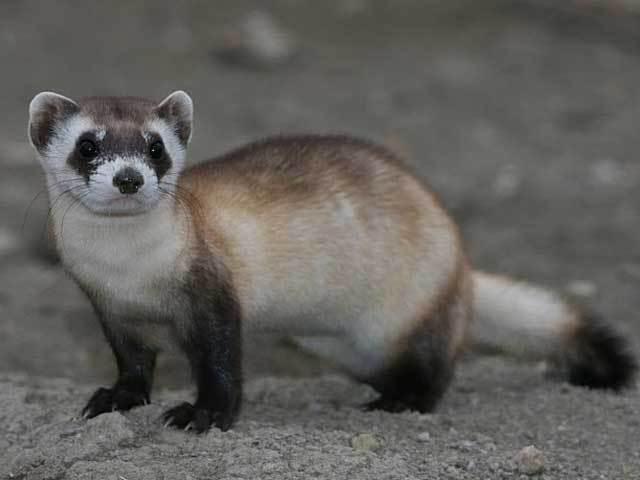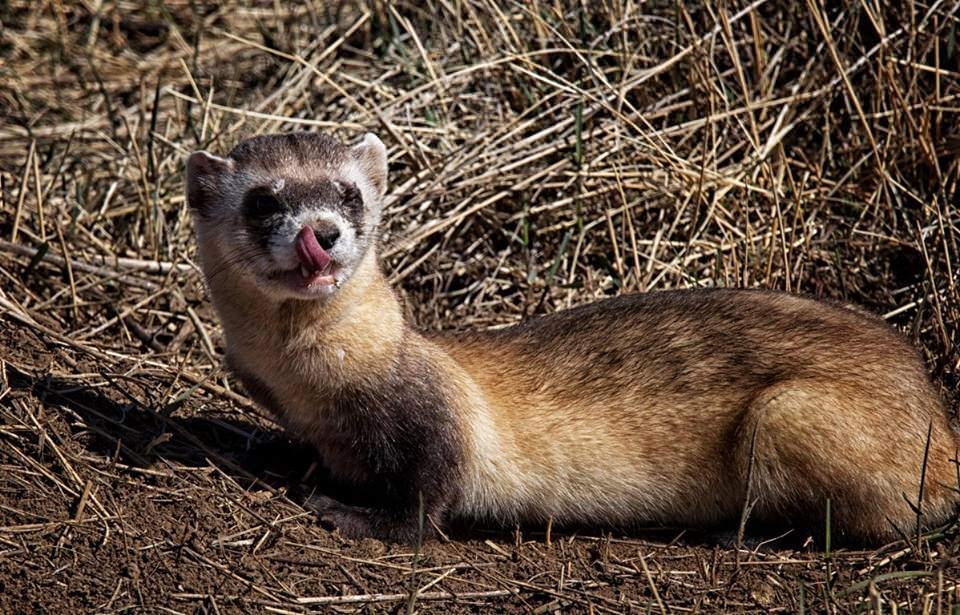The first image is the image on the left, the second image is the image on the right. Assess this claim about the two images: "In one of the images there are 2 animals.". Correct or not? Answer yes or no. No. The first image is the image on the left, the second image is the image on the right. Analyze the images presented: Is the assertion "The combined images include two ferrets in very similar poses, with heads turned the same direction, and all ferrets have raised heads." valid? Answer yes or no. Yes. 